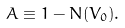Convert formula to latex. <formula><loc_0><loc_0><loc_500><loc_500>A \equiv 1 - N ( V _ { 0 } ) .</formula> 